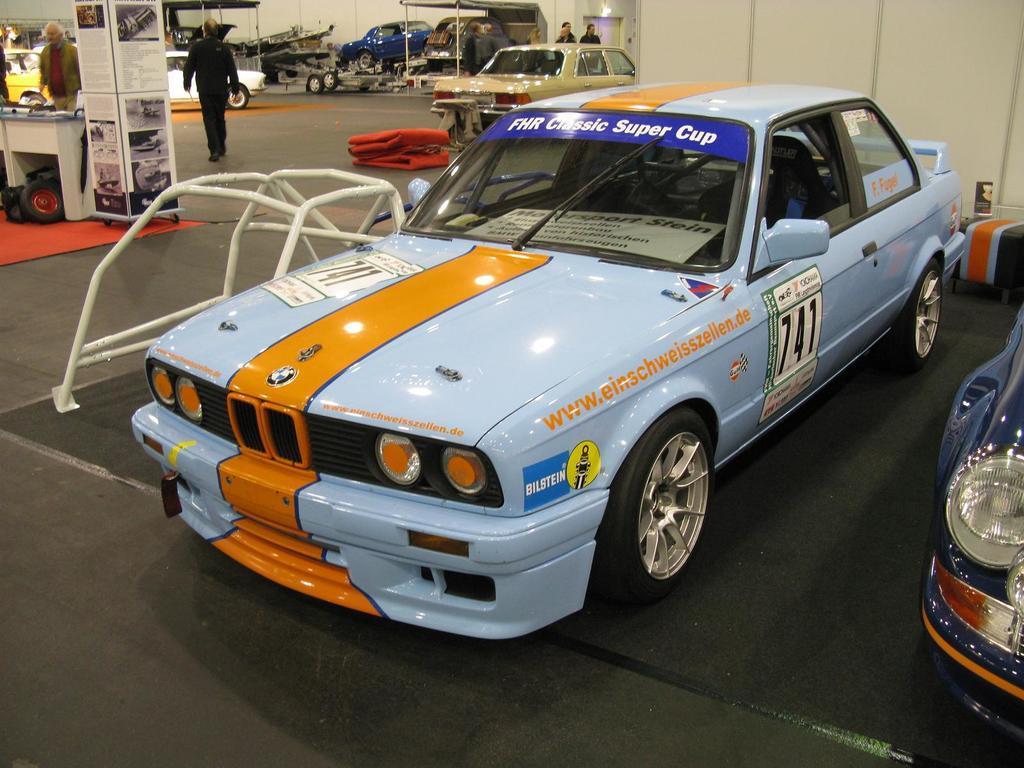Describe this image in one or two sentences. These are cars, there a person is walking. 